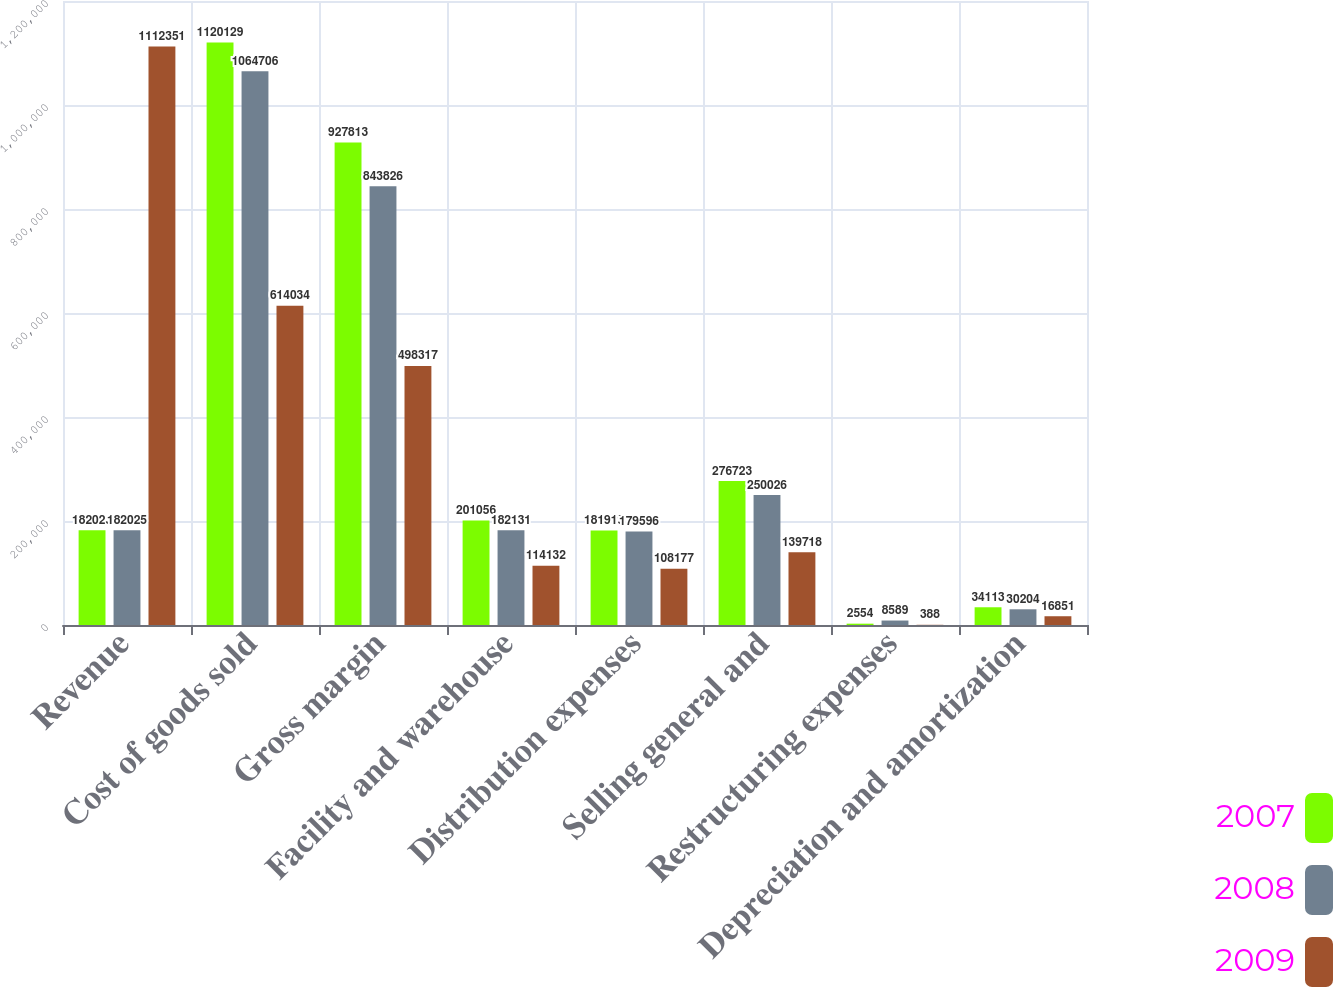Convert chart. <chart><loc_0><loc_0><loc_500><loc_500><stacked_bar_chart><ecel><fcel>Revenue<fcel>Cost of goods sold<fcel>Gross margin<fcel>Facility and warehouse<fcel>Distribution expenses<fcel>Selling general and<fcel>Restructuring expenses<fcel>Depreciation and amortization<nl><fcel>2007<fcel>182025<fcel>1.12013e+06<fcel>927813<fcel>201056<fcel>181919<fcel>276723<fcel>2554<fcel>34113<nl><fcel>2008<fcel>182025<fcel>1.06471e+06<fcel>843826<fcel>182131<fcel>179596<fcel>250026<fcel>8589<fcel>30204<nl><fcel>2009<fcel>1.11235e+06<fcel>614034<fcel>498317<fcel>114132<fcel>108177<fcel>139718<fcel>388<fcel>16851<nl></chart> 